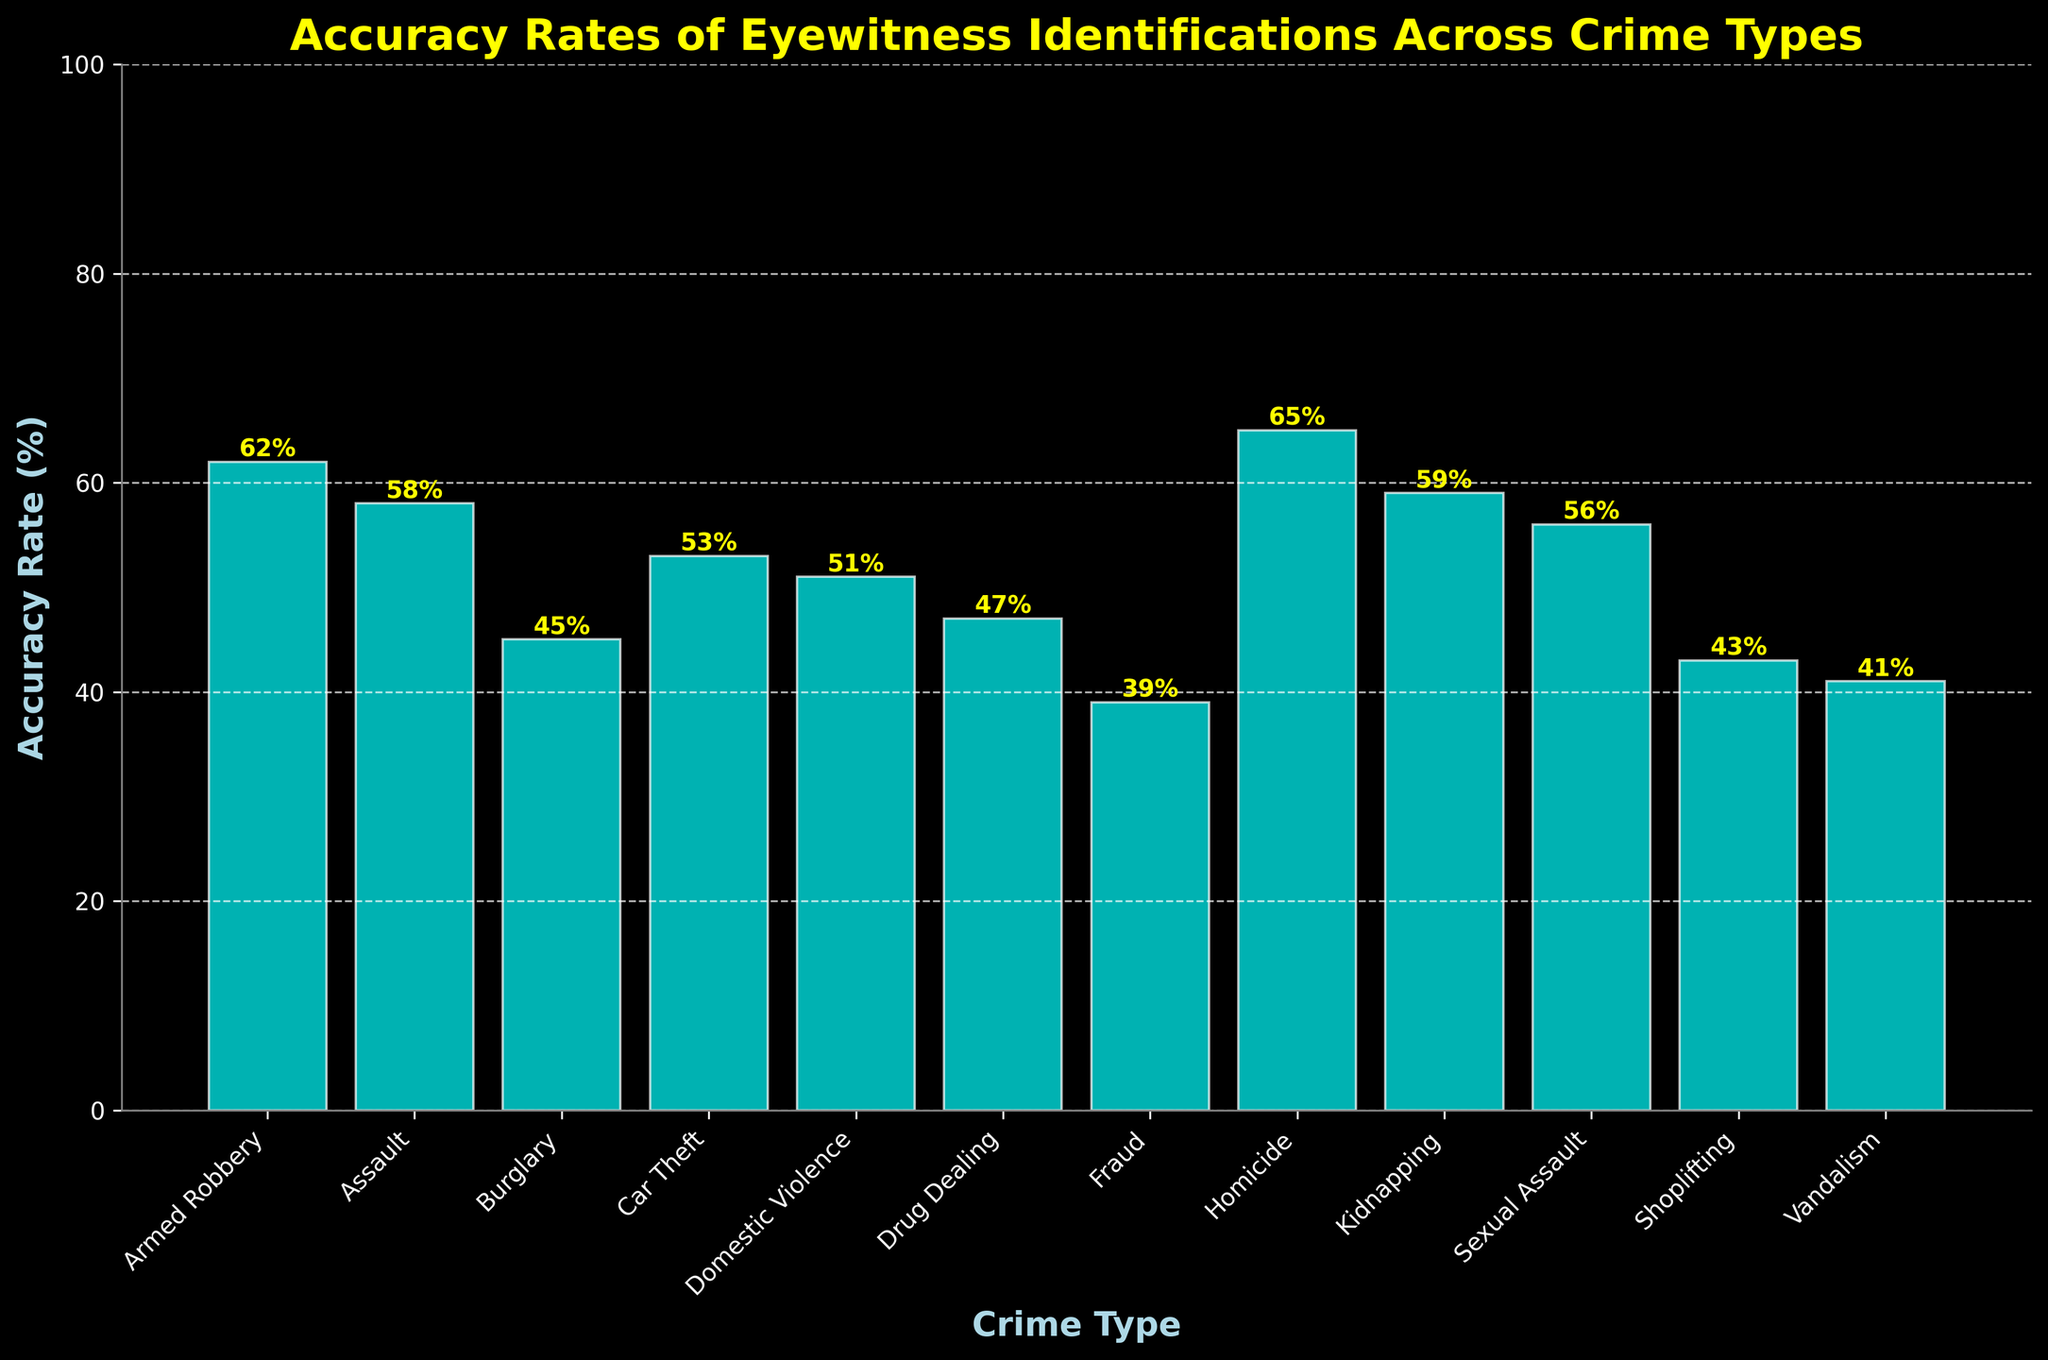Which crime type has the highest eyewitness identification accuracy rate? By examining the figure, the highest bar represents Homicide with an accuracy rate of 65%.
Answer: Homicide Which crime type has the lowest eyewitness identification accuracy rate? The shortest bar in the figure signifies Fraud with an accuracy rate of 39%.
Answer: Fraud What is the difference in accuracy rate between Armed Robbery and Burglary? The accuracy rate for Armed Robbery is 62%, and for Burglary, it is 45%. The difference is calculated as 62% - 45% = 17%.
Answer: 17% Among Assault, Car Theft, and Drug Dealing, which crime type has the highest accuracy rate? The bars for Assault (58%), Car Theft (53%), and Drug Dealing (47%) show that Assault has the highest accuracy rate of the three.
Answer: Assault What is the average accuracy rate for Kidnapping, Sexual Assault, and Domestic Violence? The accuracy rates are 59% for Kidnapping, 56% for Sexual Assault, and 51% for Domestic Violence. The sum is 59% + 56% + 51% = 166%, and the average is 166% / 3 = 55.33%.
Answer: 55.33% How many crime types have an accuracy rate above 50%? By inspecting the heights of the bars, the crime types with accuracy rates above 50% are Armed Robbery, Assault, Car Theft, Domestic Violence, Homicide, Kidnapping, and Sexual Assault. This totals to 7 crime types.
Answer: 7 Is the accuracy rate of Shoplifting higher or lower than that of Vandalism? Comparing the bars, Shoplifting has an accuracy rate of 43%, which is higher than Vandalism's 41%.
Answer: Higher What is the median accuracy rate of all the crime types depicted? To find the median, list the accuracy rates in order: 39, 41, 43, 45, 47, 51, 53, 56, 58, 59, 62, 65. The middle two values are 51 and 53. The median is their average: (51 + 53) / 2 = 52%.
Answer: 52% Which crime types have a higher accuracy rate than Drug Dealing but lower than Homicide? Drug Dealing has an accuracy rate of 47%, and Homicide has 65%. Crime types within this range are Domestic Violence (51%), Car Theft (53%), Sexual Assault (56%), Assault (58%), and Kidnapping (59%).
Answer: Domestic Violence, Car Theft, Sexual Assault, Assault, Kidnapping 